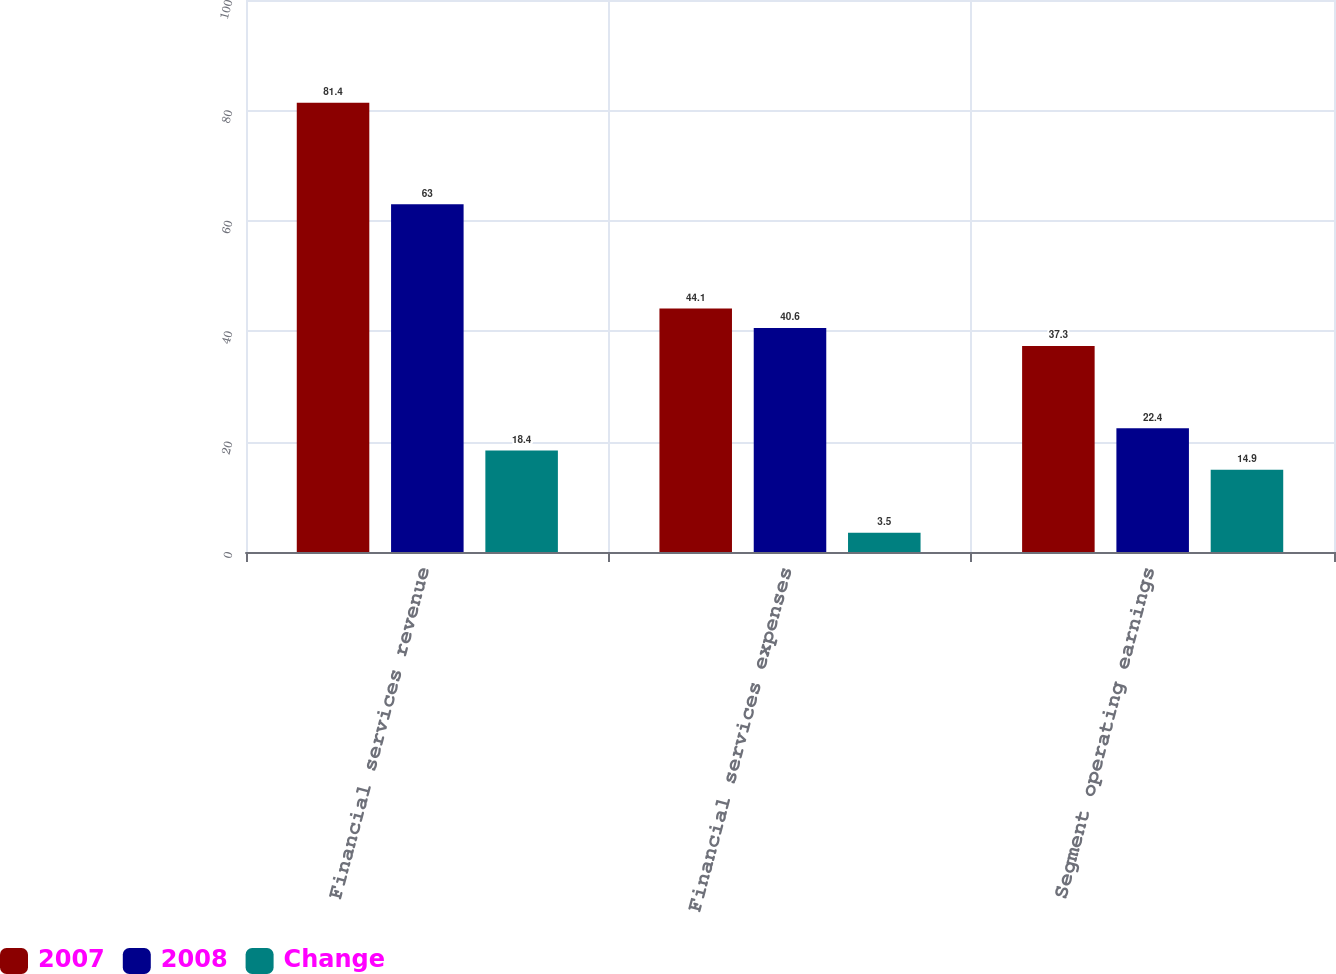Convert chart to OTSL. <chart><loc_0><loc_0><loc_500><loc_500><stacked_bar_chart><ecel><fcel>Financial services revenue<fcel>Financial services expenses<fcel>Segment operating earnings<nl><fcel>2007<fcel>81.4<fcel>44.1<fcel>37.3<nl><fcel>2008<fcel>63<fcel>40.6<fcel>22.4<nl><fcel>Change<fcel>18.4<fcel>3.5<fcel>14.9<nl></chart> 